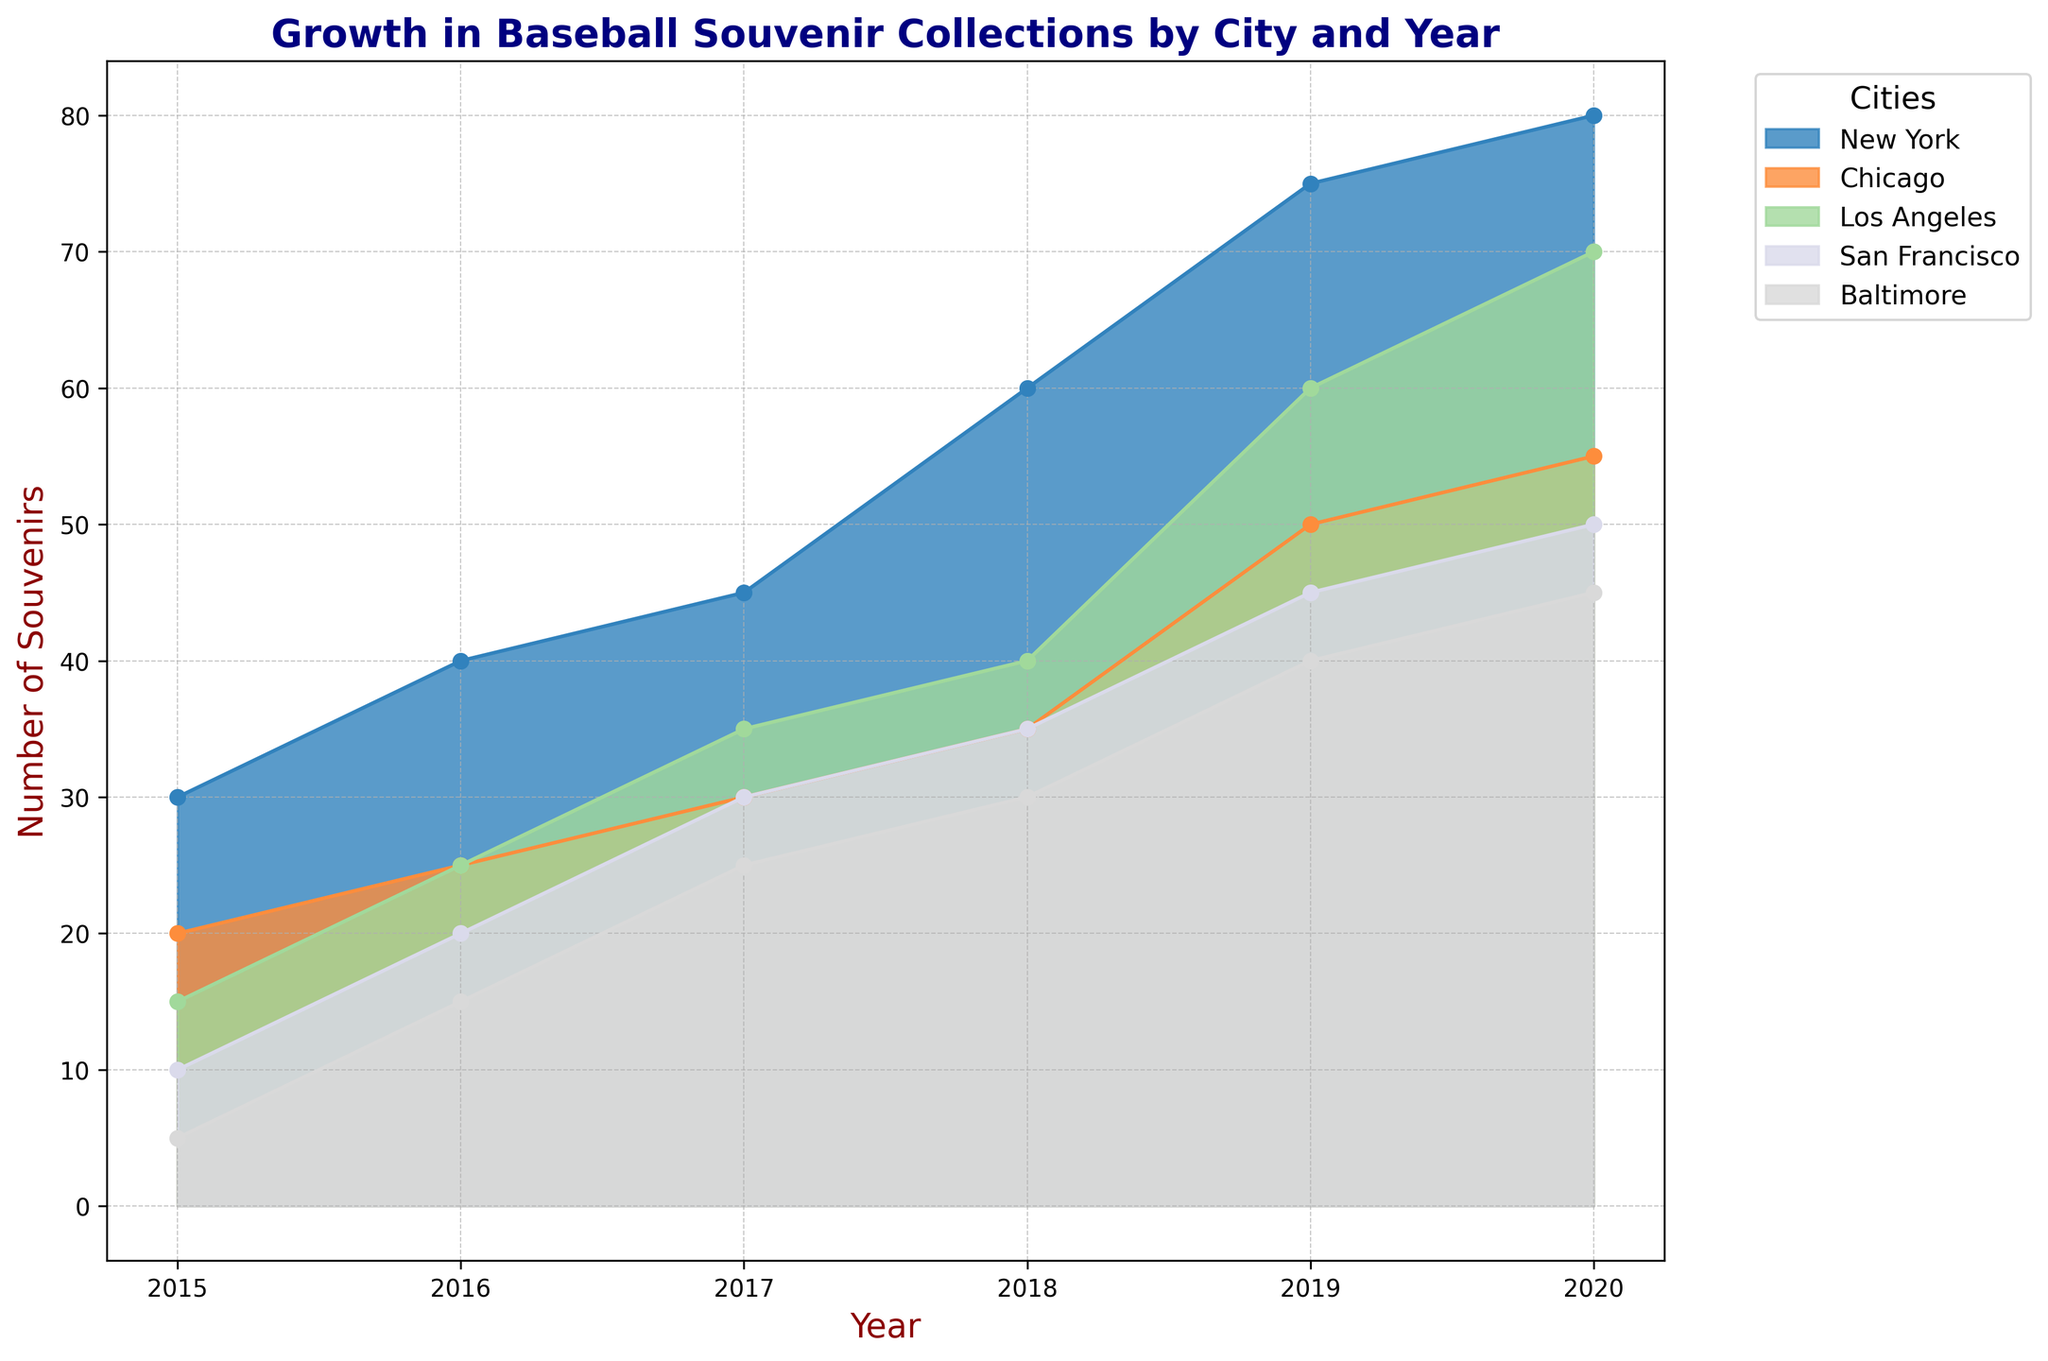Which city had the highest number of souvenirs in 2020? Look at the heights of the peaks in 2020 for all cities. The highest peak represents the city with the most souvenirs.
Answer: New York Which city had the least growth in souvenirs from 2015 to 2020? Compare the difference in the number of souvenirs between 2015 and 2020 across all cities. The city with the smallest increase had the least growth.
Answer: Baltimore What is the total number of souvenirs collected in 2020 across all cities? Add the number of souvenirs from all cities for the year 2020. The values are 80 (New York), 55 (Chicago), 70 (Los Angeles), 50 (San Francisco), and 45 (Baltimore). The total is 80 + 55 + 70 + 50 + 45.
Answer: 300 Which city had the fastest growth rate in souvenirs between 2019 and 2020? Calculate the growth rate by finding the difference between 2020 and 2019 for each city, then identify the city with the highest difference.
Answer: Los Angeles How did New York's souvenir collection change from 2015 to 2019? Identify the data points for New York from 2015 to 2019 and observe the change in the number of souvenirs year by year: 30 (2015), 40 (2016), 45 (2017), 60 (2018), 75 (2019).
Answer: Increased every year Which two cities had the most similar number of souvenirs in 2017? Compare the number of souvenirs for each city in 2017. The cities with the closest number of souvenirs are the most similar: New York (45), Chicago (30), Los Angeles (35), San Francisco (30), and Baltimore (25).
Answer: Chicago and San Francisco What was the average number of souvenirs collected per city in 2018? Add the number of souvenirs collected in 2018 for all cities and divide by the number of cities. The values are 60 (New York), 35 (Chicago), 40 (Los Angeles), 35 (San Francisco), and 30 (Baltimore). The average is (60 + 35 + 40 + 35 + 30) / 5.
Answer: 40 Did any city experience a decline in the number of souvenirs collected between any two consecutive years? Examine the trends for each city year by year. Look for any period where the number of souvenirs decreased.
Answer: No Which city had the most consecutive years of increasing souvenir collections? Track each city’s year-by-year data. Count the years of increase without interruption and identify the longest sequence.
Answer: New York 